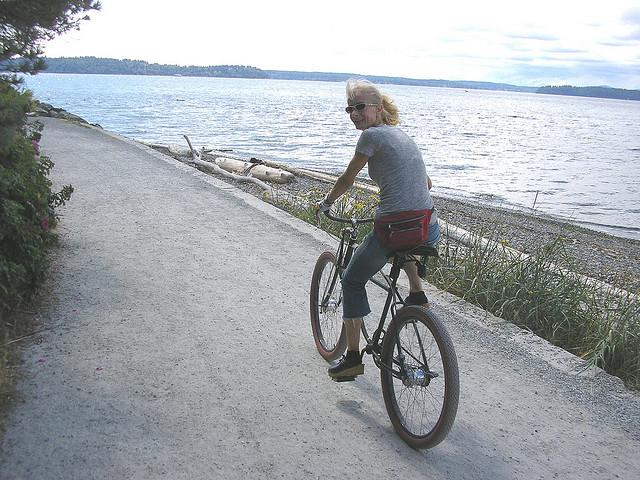Which wrong furnishing has the woman put on? shoes 